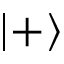Convert formula to latex. <formula><loc_0><loc_0><loc_500><loc_500>\left | + \right \rangle</formula> 